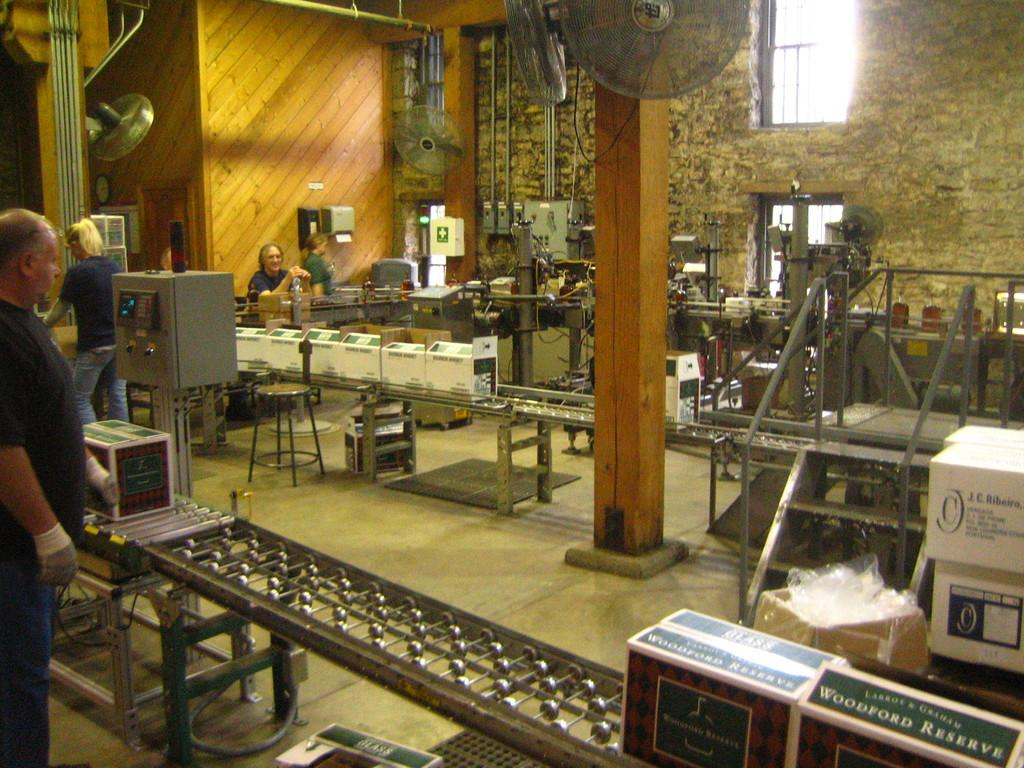<image>
Create a compact narrative representing the image presented. A wine boxing assembly line featuring Woodford Reserve. 